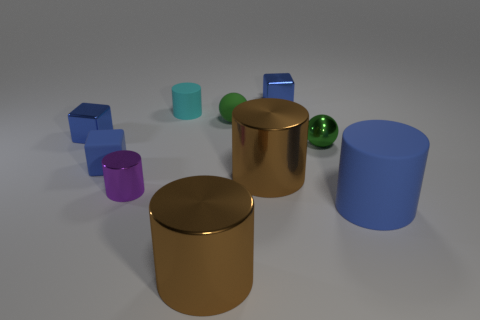There is a blue object that is right of the purple shiny object and behind the tiny purple metallic thing; what shape is it?
Your answer should be very brief. Cube. The cylinder in front of the big blue matte cylinder is what color?
Give a very brief answer. Brown. There is a metallic cylinder that is behind the large blue object and right of the tiny purple shiny cylinder; what is its size?
Ensure brevity in your answer.  Large. Is the material of the small purple thing the same as the tiny blue object on the right side of the small matte cylinder?
Your response must be concise. Yes. How many large rubber objects are the same shape as the small cyan rubber object?
Provide a short and direct response. 1. There is another tiny sphere that is the same color as the tiny shiny sphere; what material is it?
Provide a short and direct response. Rubber. How many cyan spheres are there?
Provide a short and direct response. 0. There is a tiny blue matte object; does it have the same shape as the green matte thing behind the purple cylinder?
Your answer should be compact. No. How many things are either big green things or green objects on the right side of the tiny metallic cylinder?
Keep it short and to the point. 2. What is the material of the purple object that is the same shape as the large blue matte thing?
Your answer should be very brief. Metal. 